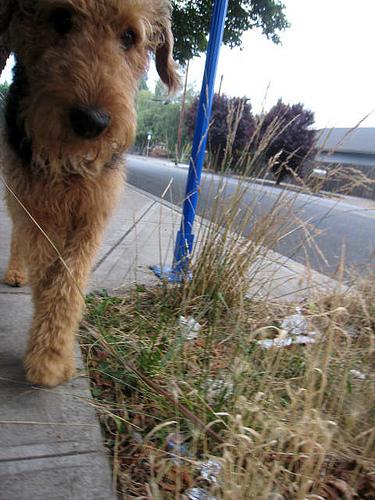Is this a dog trying to jump?
Answer briefly. No. Does the grass need to be mowed?
Quick response, please. Yes. Where is the dog walking?
Write a very short answer. Sidewalk. Can this toy walk?
Be succinct. Yes. Is the dog's tongue visible?
Quick response, please. No. 